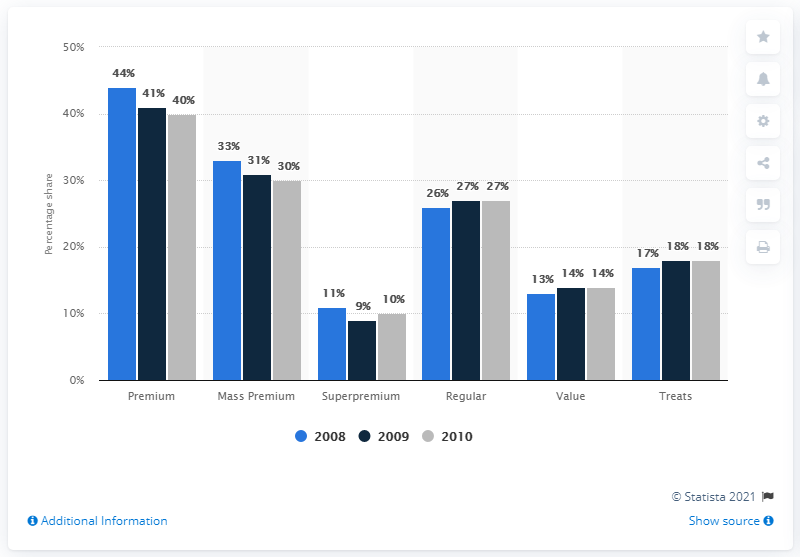Point out several critical features in this image. In 2008, the retail sale of dog and cat food accounted for approximately 33% of its mass premium market share. The retail sales of dog and cat food in the regular category accounted for approximately 80% of the total share of these sales. 